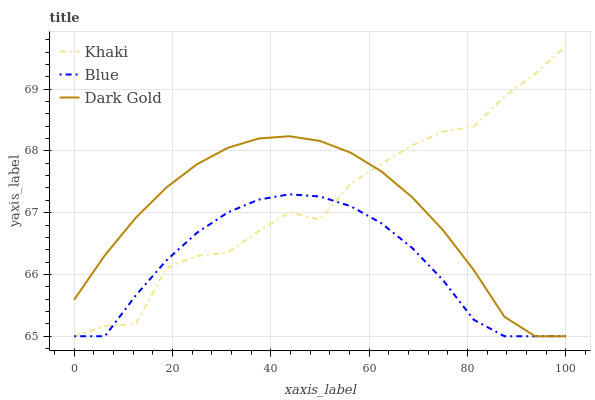Does Blue have the minimum area under the curve?
Answer yes or no. Yes. Does Khaki have the maximum area under the curve?
Answer yes or no. Yes. Does Dark Gold have the minimum area under the curve?
Answer yes or no. No. Does Dark Gold have the maximum area under the curve?
Answer yes or no. No. Is Dark Gold the smoothest?
Answer yes or no. Yes. Is Khaki the roughest?
Answer yes or no. Yes. Is Khaki the smoothest?
Answer yes or no. No. Is Dark Gold the roughest?
Answer yes or no. No. Does Blue have the lowest value?
Answer yes or no. Yes. Does Khaki have the highest value?
Answer yes or no. Yes. Does Dark Gold have the highest value?
Answer yes or no. No. Does Blue intersect Dark Gold?
Answer yes or no. Yes. Is Blue less than Dark Gold?
Answer yes or no. No. Is Blue greater than Dark Gold?
Answer yes or no. No. 